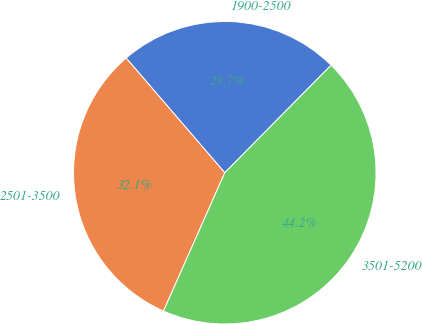<chart> <loc_0><loc_0><loc_500><loc_500><pie_chart><fcel>1900-2500<fcel>2501-3500<fcel>3501-5200<nl><fcel>23.71%<fcel>32.06%<fcel>44.23%<nl></chart> 